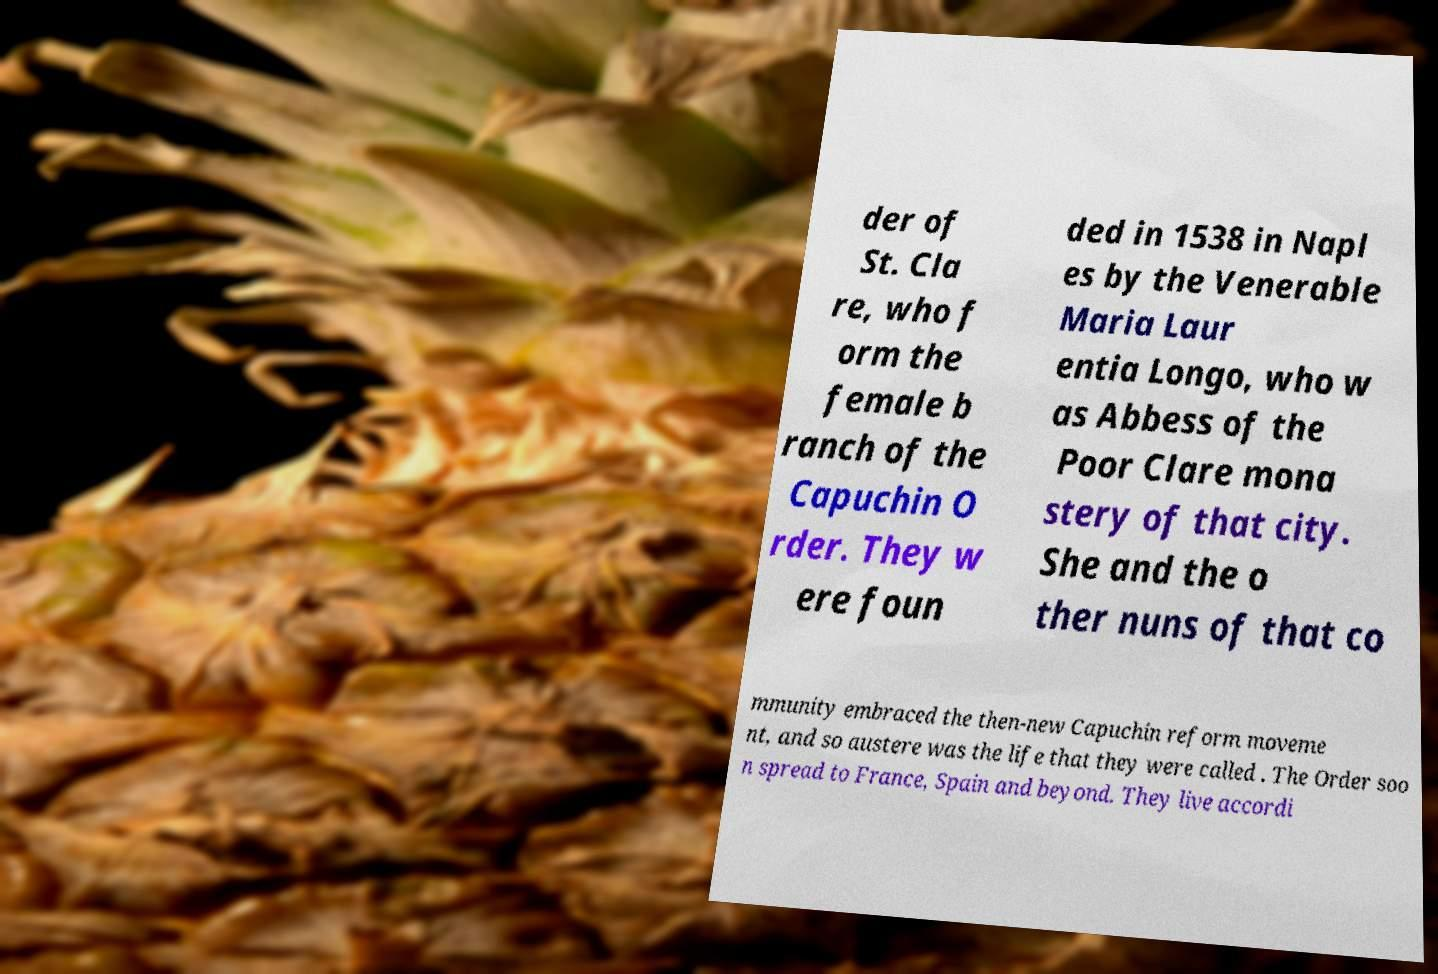Could you assist in decoding the text presented in this image and type it out clearly? der of St. Cla re, who f orm the female b ranch of the Capuchin O rder. They w ere foun ded in 1538 in Napl es by the Venerable Maria Laur entia Longo, who w as Abbess of the Poor Clare mona stery of that city. She and the o ther nuns of that co mmunity embraced the then-new Capuchin reform moveme nt, and so austere was the life that they were called . The Order soo n spread to France, Spain and beyond. They live accordi 